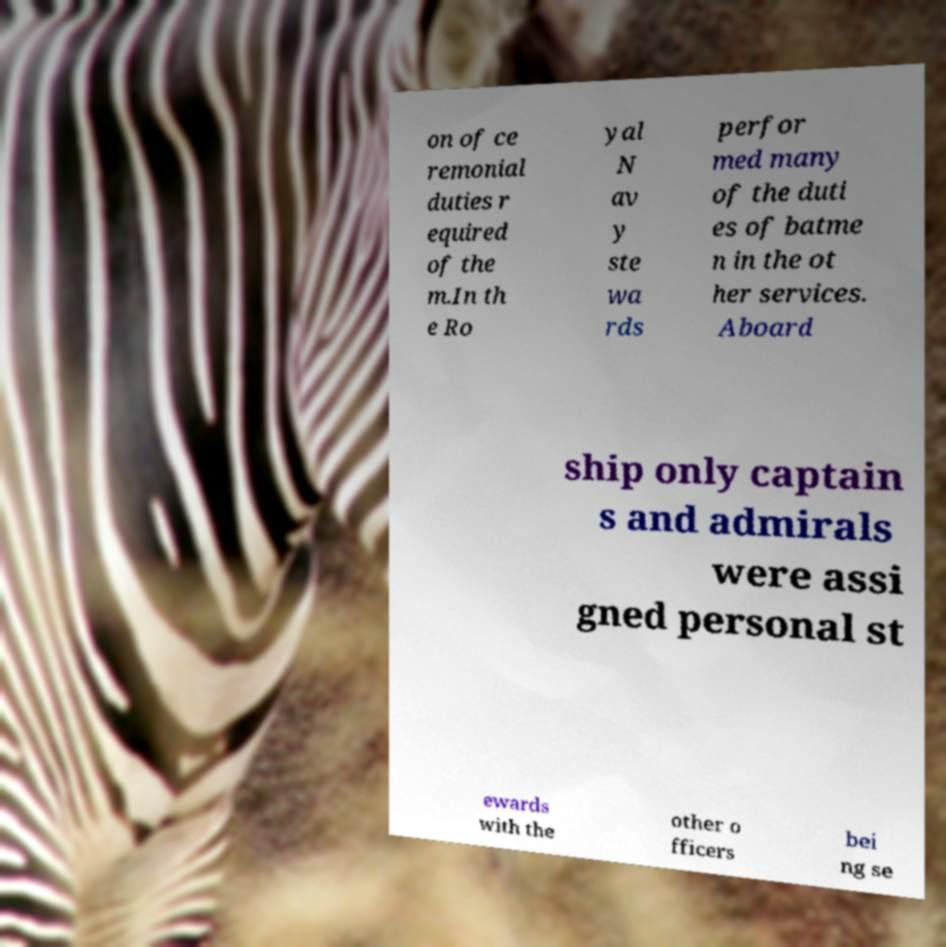There's text embedded in this image that I need extracted. Can you transcribe it verbatim? on of ce remonial duties r equired of the m.In th e Ro yal N av y ste wa rds perfor med many of the duti es of batme n in the ot her services. Aboard ship only captain s and admirals were assi gned personal st ewards with the other o fficers bei ng se 